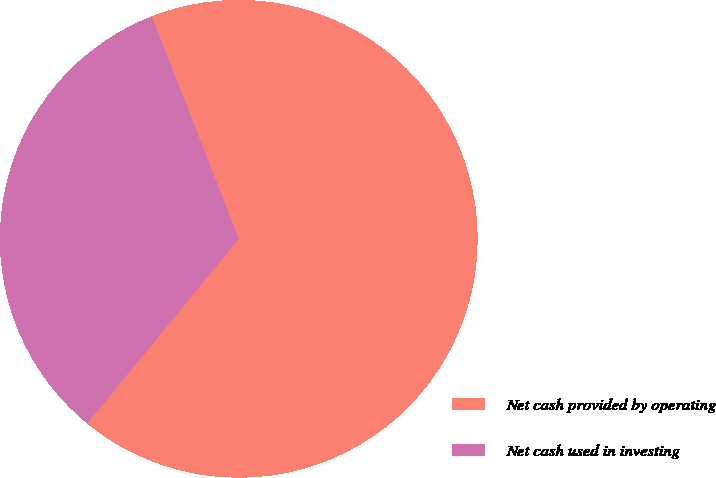Convert chart to OTSL. <chart><loc_0><loc_0><loc_500><loc_500><pie_chart><fcel>Net cash provided by operating<fcel>Net cash used in investing<nl><fcel>66.88%<fcel>33.12%<nl></chart> 